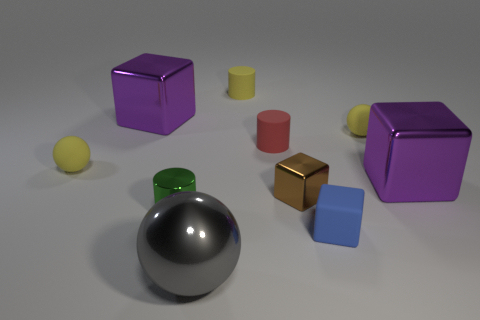Is the shape of the matte thing that is to the left of the gray shiny thing the same as  the gray metallic thing?
Your answer should be compact. Yes. There is a ball to the right of the gray shiny thing; are there any yellow balls that are right of it?
Provide a short and direct response. No. There is a purple block on the left side of the blue thing; what material is it?
Offer a terse response. Metal. Do the tiny green shiny object and the small blue matte object have the same shape?
Your answer should be very brief. No. There is a big cube in front of the large shiny object behind the ball to the right of the small blue matte cube; what color is it?
Your answer should be compact. Purple. What number of red objects have the same shape as the green thing?
Give a very brief answer. 1. There is a metallic ball that is right of the big metal thing behind the tiny red matte object; what size is it?
Your answer should be very brief. Large. Does the gray metallic sphere have the same size as the blue matte thing?
Offer a terse response. No. Are there any rubber things to the left of the large purple block left of the sphere right of the red rubber cylinder?
Your answer should be very brief. Yes. How big is the brown block?
Make the answer very short. Small. 